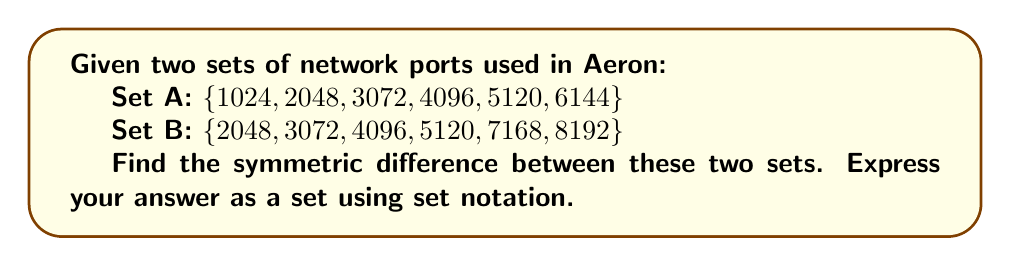Can you answer this question? To find the symmetric difference between two sets, we need to follow these steps:

1. The symmetric difference of sets A and B is defined as the set of elements that are in either A or B, but not in both. It can be expressed as $(A \cup B) \setminus (A \cap B)$.

2. First, let's find the union of A and B:
   $A \cup B = \{1024, 2048, 3072, 4096, 5120, 6144, 7168, 8192\}$

3. Next, let's find the intersection of A and B:
   $A \cap B = \{2048, 3072, 4096, 5120\}$

4. Now, we need to find the elements that are in the union but not in the intersection:

   - Elements in $A \cup B$: 1024, 2048, 3072, 4096, 5120, 6144, 7168, 8192
   - Elements in $A \cap B$: 2048, 3072, 4096, 5120
   - Elements in $(A \cup B) \setminus (A \cap B)$: 1024, 6144, 7168, 8192

5. Therefore, the symmetric difference is the set containing these elements.

In the context of Aeron network ports, these would represent the ports that are used exclusively by one set but not the other, which could be important for configuring unique communication channels or identifying potential conflicts in port usage.
Answer: $\{1024, 6144, 7168, 8192\}$ 